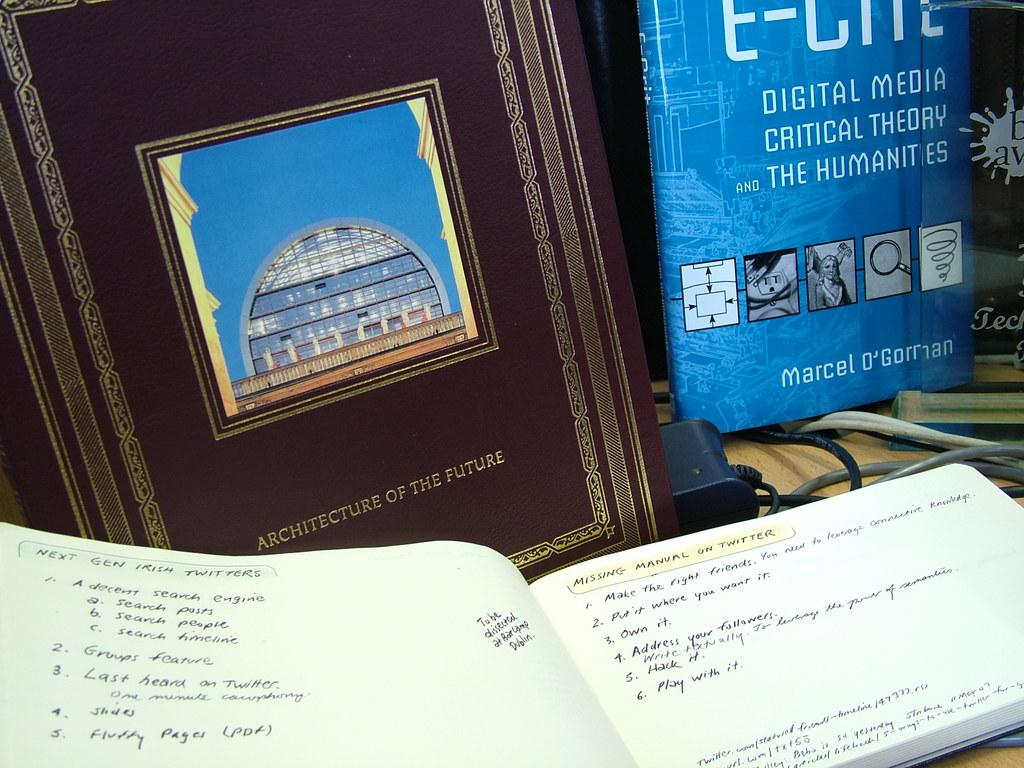<image>
Offer a succinct explanation of the picture presented. A book is propped up next to a frame that is authored by someone named Marcel. 